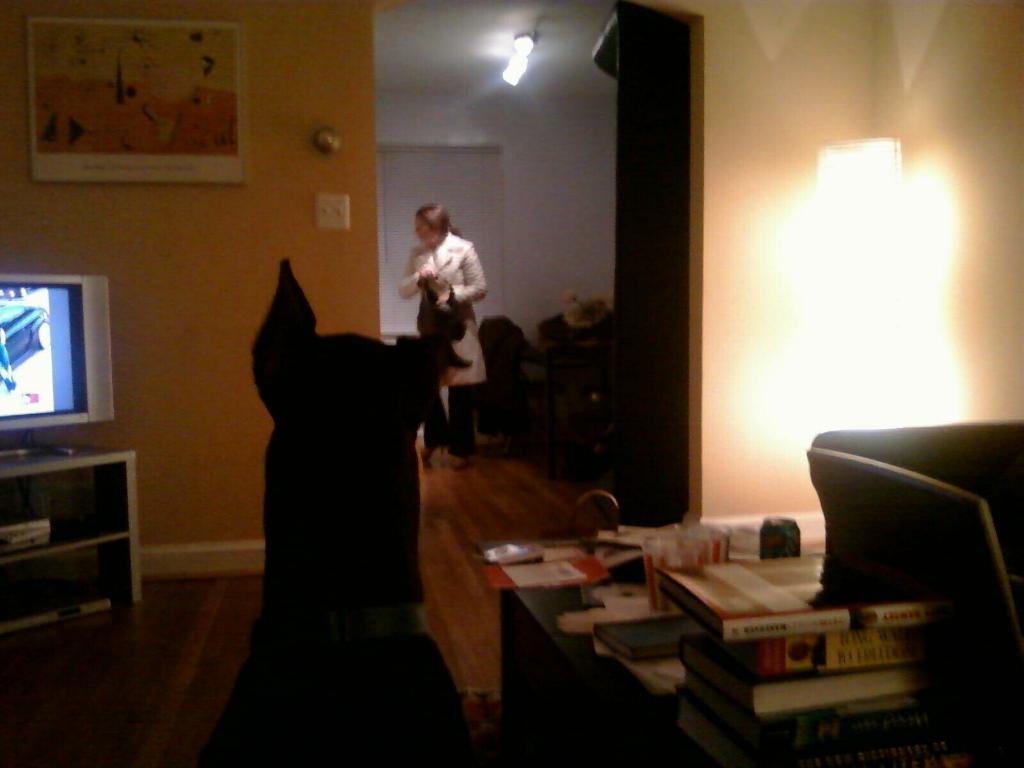Could you give a brief overview of what you see in this image? In this picture we can see a dog some books on the desk, television and a woman. 